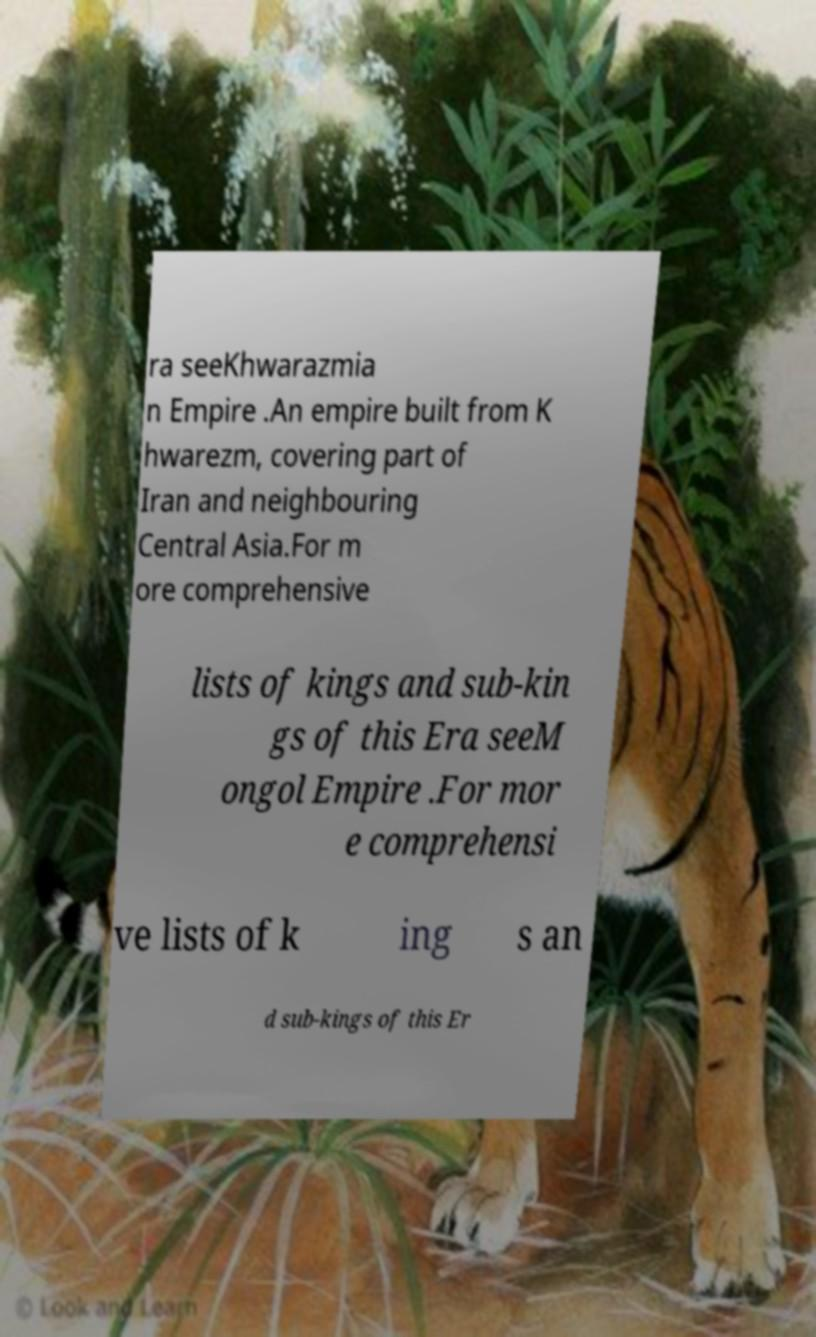Please read and relay the text visible in this image. What does it say? ra seeKhwarazmia n Empire .An empire built from K hwarezm, covering part of Iran and neighbouring Central Asia.For m ore comprehensive lists of kings and sub-kin gs of this Era seeM ongol Empire .For mor e comprehensi ve lists of k ing s an d sub-kings of this Er 